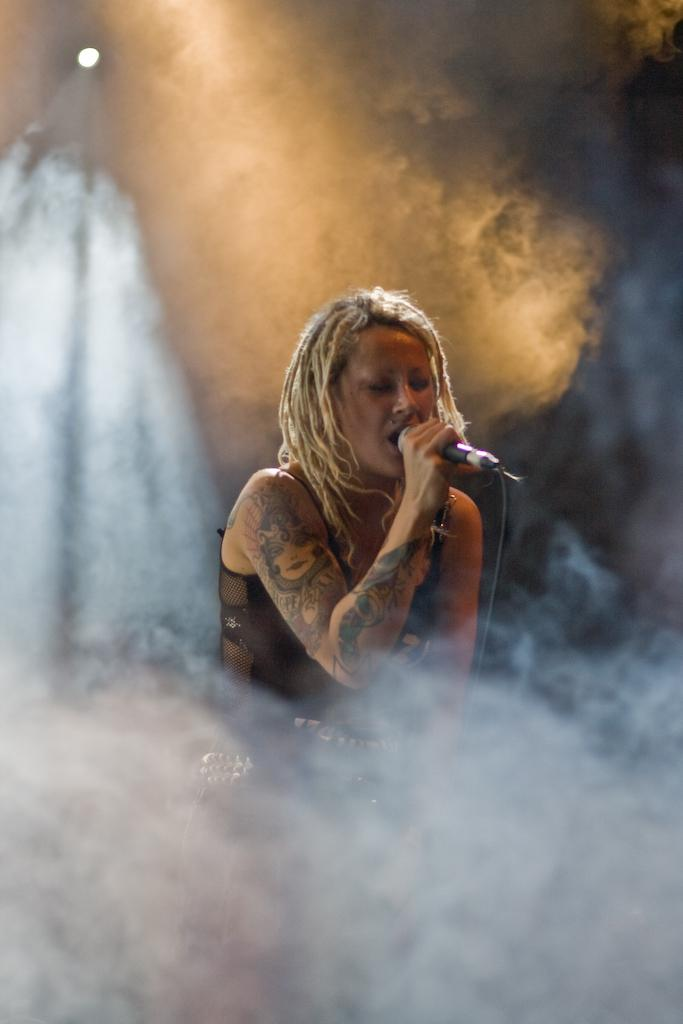What is the woman in the image holding? The woman is holding a mic. What is the woman doing in the image? The woman is singing. Can you describe any visual effects in the image? Yes, there is smoke visible in the image. What is located at the top of the image? There is a light at the top of the image. What type of crush can be seen on the tray in the image? There is no tray or crush present in the image. What is the woman's desire in the image? The image does not provide information about the woman's desires. 